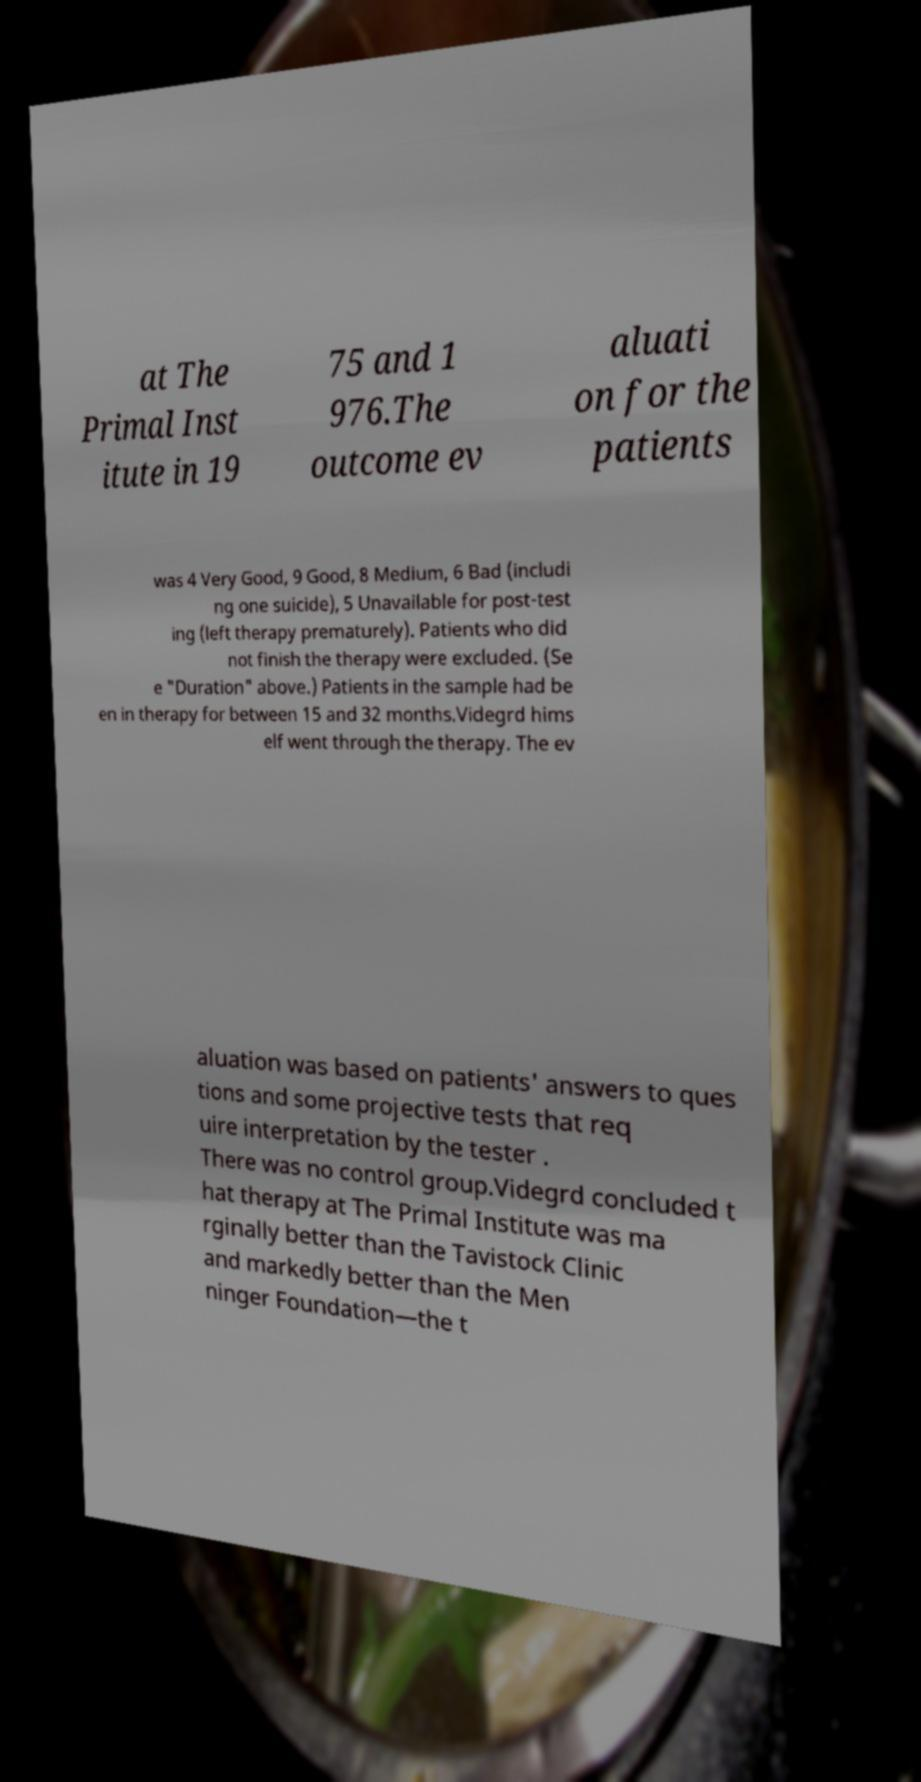There's text embedded in this image that I need extracted. Can you transcribe it verbatim? at The Primal Inst itute in 19 75 and 1 976.The outcome ev aluati on for the patients was 4 Very Good, 9 Good, 8 Medium, 6 Bad (includi ng one suicide), 5 Unavailable for post-test ing (left therapy prematurely). Patients who did not finish the therapy were excluded. (Se e "Duration" above.) Patients in the sample had be en in therapy for between 15 and 32 months.Videgrd hims elf went through the therapy. The ev aluation was based on patients' answers to ques tions and some projective tests that req uire interpretation by the tester . There was no control group.Videgrd concluded t hat therapy at The Primal Institute was ma rginally better than the Tavistock Clinic and markedly better than the Men ninger Foundation—the t 